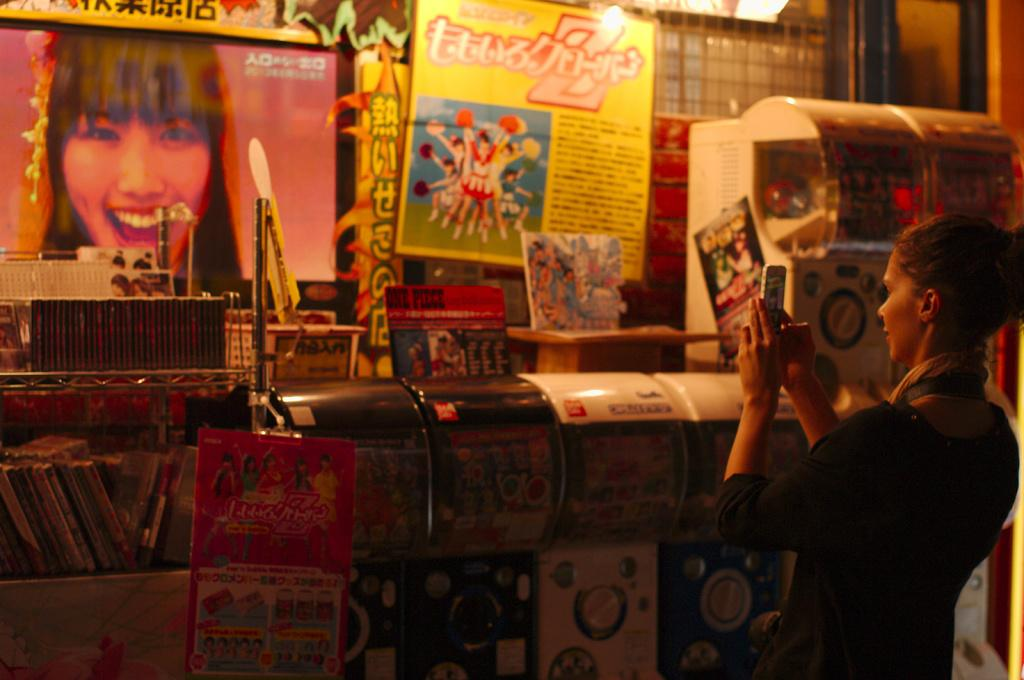What is the person in the image doing? The person is standing in the image and holding a mobile. What else can be seen in the image besides the person? There are books, machines, posters, and other objects in the image. Can you describe the machines in the image? Unfortunately, the facts provided do not give specific details about the machines in the image. What type of objects are present in the image besides the ones mentioned? The facts provided do not specify the other objects in the image. What type of grass can be seen growing around the truck in the image? There is no truck or grass present in the image. How many oranges are visible on the trees in the image? There are no trees or oranges present in the image. 